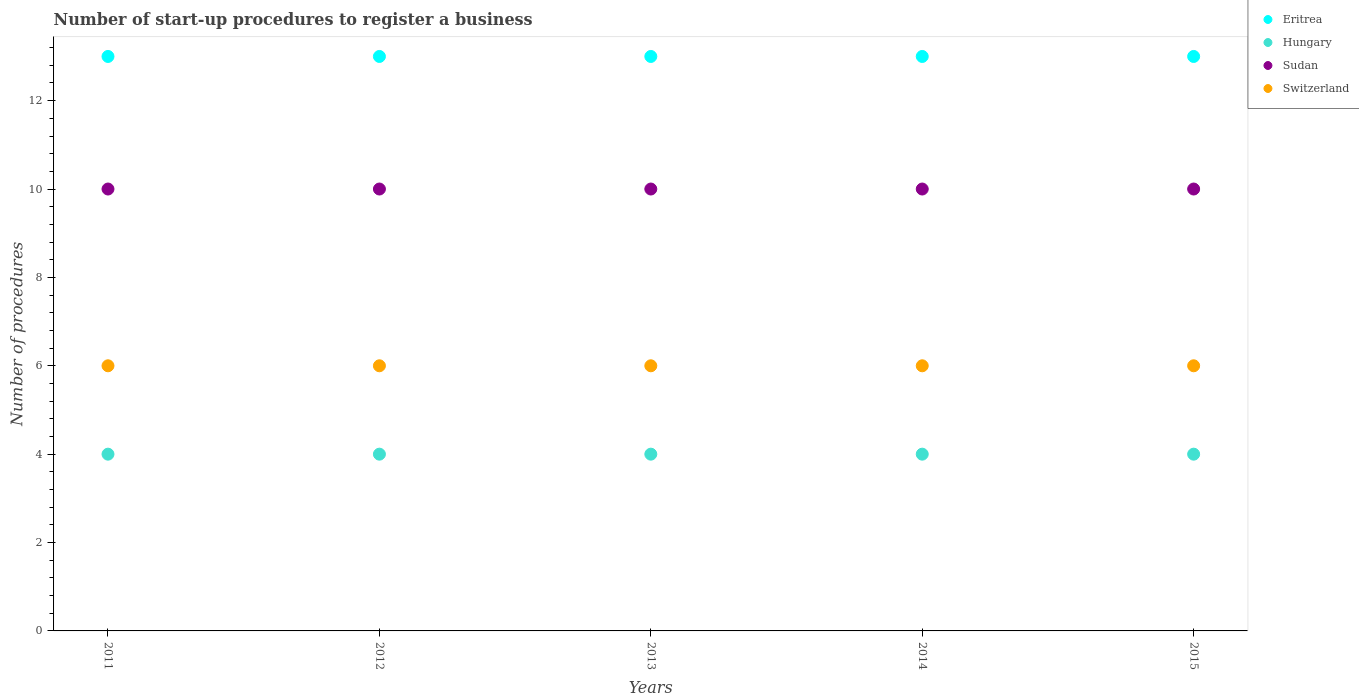What is the number of procedures required to register a business in Hungary in 2014?
Your answer should be very brief. 4. Across all years, what is the maximum number of procedures required to register a business in Switzerland?
Provide a succinct answer. 6. Across all years, what is the minimum number of procedures required to register a business in Hungary?
Your answer should be very brief. 4. In which year was the number of procedures required to register a business in Hungary minimum?
Your response must be concise. 2011. What is the difference between the number of procedures required to register a business in Hungary in 2011 and that in 2015?
Provide a short and direct response. 0. What is the difference between the number of procedures required to register a business in Hungary in 2014 and the number of procedures required to register a business in Switzerland in 2012?
Your answer should be compact. -2. What is the average number of procedures required to register a business in Switzerland per year?
Provide a short and direct response. 6. In the year 2012, what is the difference between the number of procedures required to register a business in Eritrea and number of procedures required to register a business in Hungary?
Make the answer very short. 9. Is the number of procedures required to register a business in Eritrea in 2011 less than that in 2012?
Make the answer very short. No. Is the difference between the number of procedures required to register a business in Eritrea in 2011 and 2012 greater than the difference between the number of procedures required to register a business in Hungary in 2011 and 2012?
Ensure brevity in your answer.  No. What is the difference between the highest and the lowest number of procedures required to register a business in Hungary?
Give a very brief answer. 0. Is the sum of the number of procedures required to register a business in Sudan in 2013 and 2014 greater than the maximum number of procedures required to register a business in Hungary across all years?
Your response must be concise. Yes. Is it the case that in every year, the sum of the number of procedures required to register a business in Switzerland and number of procedures required to register a business in Eritrea  is greater than the number of procedures required to register a business in Hungary?
Keep it short and to the point. Yes. Is the number of procedures required to register a business in Eritrea strictly greater than the number of procedures required to register a business in Sudan over the years?
Ensure brevity in your answer.  Yes. What is the difference between two consecutive major ticks on the Y-axis?
Your answer should be compact. 2. Are the values on the major ticks of Y-axis written in scientific E-notation?
Your answer should be very brief. No. What is the title of the graph?
Give a very brief answer. Number of start-up procedures to register a business. What is the label or title of the Y-axis?
Offer a terse response. Number of procedures. What is the Number of procedures of Hungary in 2011?
Provide a succinct answer. 4. What is the Number of procedures in Switzerland in 2011?
Ensure brevity in your answer.  6. What is the Number of procedures of Hungary in 2012?
Provide a succinct answer. 4. What is the Number of procedures of Switzerland in 2012?
Make the answer very short. 6. What is the Number of procedures in Eritrea in 2013?
Keep it short and to the point. 13. What is the Number of procedures in Hungary in 2013?
Keep it short and to the point. 4. What is the Number of procedures of Eritrea in 2014?
Provide a short and direct response. 13. What is the Number of procedures of Hungary in 2014?
Offer a terse response. 4. What is the Number of procedures of Sudan in 2014?
Provide a short and direct response. 10. What is the Number of procedures of Switzerland in 2014?
Make the answer very short. 6. What is the Number of procedures in Hungary in 2015?
Your answer should be compact. 4. Across all years, what is the maximum Number of procedures of Hungary?
Offer a very short reply. 4. Across all years, what is the minimum Number of procedures of Sudan?
Your response must be concise. 10. What is the total Number of procedures in Eritrea in the graph?
Offer a very short reply. 65. What is the total Number of procedures of Sudan in the graph?
Your answer should be very brief. 50. What is the total Number of procedures in Switzerland in the graph?
Offer a very short reply. 30. What is the difference between the Number of procedures in Hungary in 2011 and that in 2012?
Provide a short and direct response. 0. What is the difference between the Number of procedures of Switzerland in 2011 and that in 2012?
Offer a terse response. 0. What is the difference between the Number of procedures of Eritrea in 2011 and that in 2013?
Give a very brief answer. 0. What is the difference between the Number of procedures of Sudan in 2011 and that in 2013?
Make the answer very short. 0. What is the difference between the Number of procedures in Eritrea in 2011 and that in 2014?
Offer a very short reply. 0. What is the difference between the Number of procedures in Eritrea in 2011 and that in 2015?
Your answer should be compact. 0. What is the difference between the Number of procedures of Hungary in 2011 and that in 2015?
Make the answer very short. 0. What is the difference between the Number of procedures of Sudan in 2011 and that in 2015?
Keep it short and to the point. 0. What is the difference between the Number of procedures in Switzerland in 2011 and that in 2015?
Your response must be concise. 0. What is the difference between the Number of procedures in Hungary in 2012 and that in 2013?
Your response must be concise. 0. What is the difference between the Number of procedures of Switzerland in 2012 and that in 2013?
Make the answer very short. 0. What is the difference between the Number of procedures of Eritrea in 2012 and that in 2014?
Offer a very short reply. 0. What is the difference between the Number of procedures of Switzerland in 2012 and that in 2014?
Make the answer very short. 0. What is the difference between the Number of procedures in Eritrea in 2012 and that in 2015?
Your response must be concise. 0. What is the difference between the Number of procedures of Hungary in 2012 and that in 2015?
Make the answer very short. 0. What is the difference between the Number of procedures of Eritrea in 2013 and that in 2014?
Ensure brevity in your answer.  0. What is the difference between the Number of procedures of Hungary in 2013 and that in 2014?
Your response must be concise. 0. What is the difference between the Number of procedures in Switzerland in 2013 and that in 2014?
Make the answer very short. 0. What is the difference between the Number of procedures of Hungary in 2013 and that in 2015?
Keep it short and to the point. 0. What is the difference between the Number of procedures of Sudan in 2013 and that in 2015?
Make the answer very short. 0. What is the difference between the Number of procedures of Switzerland in 2013 and that in 2015?
Provide a succinct answer. 0. What is the difference between the Number of procedures of Eritrea in 2014 and that in 2015?
Provide a succinct answer. 0. What is the difference between the Number of procedures in Hungary in 2014 and that in 2015?
Make the answer very short. 0. What is the difference between the Number of procedures in Switzerland in 2014 and that in 2015?
Ensure brevity in your answer.  0. What is the difference between the Number of procedures in Eritrea in 2011 and the Number of procedures in Hungary in 2012?
Provide a short and direct response. 9. What is the difference between the Number of procedures of Eritrea in 2011 and the Number of procedures of Switzerland in 2012?
Offer a very short reply. 7. What is the difference between the Number of procedures in Hungary in 2011 and the Number of procedures in Sudan in 2012?
Provide a short and direct response. -6. What is the difference between the Number of procedures in Hungary in 2011 and the Number of procedures in Switzerland in 2012?
Your response must be concise. -2. What is the difference between the Number of procedures of Sudan in 2011 and the Number of procedures of Switzerland in 2012?
Your response must be concise. 4. What is the difference between the Number of procedures of Eritrea in 2011 and the Number of procedures of Hungary in 2013?
Make the answer very short. 9. What is the difference between the Number of procedures in Eritrea in 2011 and the Number of procedures in Sudan in 2013?
Keep it short and to the point. 3. What is the difference between the Number of procedures of Eritrea in 2011 and the Number of procedures of Switzerland in 2013?
Ensure brevity in your answer.  7. What is the difference between the Number of procedures of Hungary in 2011 and the Number of procedures of Sudan in 2013?
Your response must be concise. -6. What is the difference between the Number of procedures of Eritrea in 2011 and the Number of procedures of Sudan in 2014?
Your answer should be very brief. 3. What is the difference between the Number of procedures of Eritrea in 2011 and the Number of procedures of Switzerland in 2014?
Ensure brevity in your answer.  7. What is the difference between the Number of procedures in Eritrea in 2011 and the Number of procedures in Hungary in 2015?
Give a very brief answer. 9. What is the difference between the Number of procedures in Eritrea in 2011 and the Number of procedures in Sudan in 2015?
Offer a very short reply. 3. What is the difference between the Number of procedures of Hungary in 2011 and the Number of procedures of Sudan in 2015?
Provide a short and direct response. -6. What is the difference between the Number of procedures of Hungary in 2011 and the Number of procedures of Switzerland in 2015?
Your answer should be compact. -2. What is the difference between the Number of procedures of Sudan in 2011 and the Number of procedures of Switzerland in 2015?
Make the answer very short. 4. What is the difference between the Number of procedures in Hungary in 2012 and the Number of procedures in Sudan in 2013?
Ensure brevity in your answer.  -6. What is the difference between the Number of procedures of Hungary in 2012 and the Number of procedures of Switzerland in 2013?
Ensure brevity in your answer.  -2. What is the difference between the Number of procedures of Eritrea in 2012 and the Number of procedures of Hungary in 2014?
Keep it short and to the point. 9. What is the difference between the Number of procedures in Eritrea in 2012 and the Number of procedures in Switzerland in 2014?
Keep it short and to the point. 7. What is the difference between the Number of procedures in Hungary in 2012 and the Number of procedures in Sudan in 2014?
Provide a short and direct response. -6. What is the difference between the Number of procedures in Hungary in 2012 and the Number of procedures in Switzerland in 2014?
Ensure brevity in your answer.  -2. What is the difference between the Number of procedures in Eritrea in 2012 and the Number of procedures in Sudan in 2015?
Keep it short and to the point. 3. What is the difference between the Number of procedures in Hungary in 2012 and the Number of procedures in Sudan in 2015?
Ensure brevity in your answer.  -6. What is the difference between the Number of procedures of Hungary in 2012 and the Number of procedures of Switzerland in 2015?
Ensure brevity in your answer.  -2. What is the difference between the Number of procedures in Eritrea in 2013 and the Number of procedures in Sudan in 2014?
Your response must be concise. 3. What is the difference between the Number of procedures in Hungary in 2013 and the Number of procedures in Sudan in 2014?
Keep it short and to the point. -6. What is the difference between the Number of procedures of Eritrea in 2013 and the Number of procedures of Hungary in 2015?
Your response must be concise. 9. What is the difference between the Number of procedures of Eritrea in 2013 and the Number of procedures of Switzerland in 2015?
Offer a very short reply. 7. What is the difference between the Number of procedures in Hungary in 2013 and the Number of procedures in Sudan in 2015?
Give a very brief answer. -6. What is the difference between the Number of procedures in Sudan in 2013 and the Number of procedures in Switzerland in 2015?
Give a very brief answer. 4. What is the difference between the Number of procedures of Hungary in 2014 and the Number of procedures of Sudan in 2015?
Make the answer very short. -6. What is the difference between the Number of procedures of Sudan in 2014 and the Number of procedures of Switzerland in 2015?
Your answer should be very brief. 4. What is the average Number of procedures of Sudan per year?
Provide a short and direct response. 10. What is the average Number of procedures in Switzerland per year?
Make the answer very short. 6. In the year 2011, what is the difference between the Number of procedures in Hungary and Number of procedures in Sudan?
Offer a very short reply. -6. In the year 2012, what is the difference between the Number of procedures in Eritrea and Number of procedures in Sudan?
Make the answer very short. 3. In the year 2012, what is the difference between the Number of procedures of Sudan and Number of procedures of Switzerland?
Your answer should be compact. 4. In the year 2013, what is the difference between the Number of procedures in Eritrea and Number of procedures in Hungary?
Provide a succinct answer. 9. In the year 2013, what is the difference between the Number of procedures in Hungary and Number of procedures in Switzerland?
Keep it short and to the point. -2. In the year 2013, what is the difference between the Number of procedures in Sudan and Number of procedures in Switzerland?
Offer a terse response. 4. In the year 2014, what is the difference between the Number of procedures of Eritrea and Number of procedures of Hungary?
Offer a very short reply. 9. In the year 2014, what is the difference between the Number of procedures of Sudan and Number of procedures of Switzerland?
Offer a very short reply. 4. In the year 2015, what is the difference between the Number of procedures in Eritrea and Number of procedures in Hungary?
Offer a terse response. 9. In the year 2015, what is the difference between the Number of procedures in Hungary and Number of procedures in Switzerland?
Your answer should be compact. -2. In the year 2015, what is the difference between the Number of procedures of Sudan and Number of procedures of Switzerland?
Your answer should be very brief. 4. What is the ratio of the Number of procedures of Eritrea in 2011 to that in 2012?
Keep it short and to the point. 1. What is the ratio of the Number of procedures in Sudan in 2011 to that in 2012?
Provide a succinct answer. 1. What is the ratio of the Number of procedures in Switzerland in 2011 to that in 2012?
Offer a very short reply. 1. What is the ratio of the Number of procedures in Eritrea in 2011 to that in 2013?
Provide a short and direct response. 1. What is the ratio of the Number of procedures in Hungary in 2011 to that in 2013?
Make the answer very short. 1. What is the ratio of the Number of procedures of Eritrea in 2011 to that in 2014?
Your answer should be compact. 1. What is the ratio of the Number of procedures of Hungary in 2011 to that in 2014?
Give a very brief answer. 1. What is the ratio of the Number of procedures in Switzerland in 2011 to that in 2014?
Provide a short and direct response. 1. What is the ratio of the Number of procedures of Eritrea in 2012 to that in 2013?
Give a very brief answer. 1. What is the ratio of the Number of procedures of Sudan in 2012 to that in 2013?
Provide a succinct answer. 1. What is the ratio of the Number of procedures in Eritrea in 2012 to that in 2014?
Ensure brevity in your answer.  1. What is the ratio of the Number of procedures in Switzerland in 2012 to that in 2014?
Give a very brief answer. 1. What is the ratio of the Number of procedures in Hungary in 2013 to that in 2014?
Provide a short and direct response. 1. What is the ratio of the Number of procedures of Sudan in 2013 to that in 2014?
Your answer should be very brief. 1. What is the ratio of the Number of procedures of Eritrea in 2013 to that in 2015?
Give a very brief answer. 1. What is the ratio of the Number of procedures of Sudan in 2013 to that in 2015?
Ensure brevity in your answer.  1. What is the ratio of the Number of procedures of Hungary in 2014 to that in 2015?
Offer a very short reply. 1. What is the difference between the highest and the second highest Number of procedures of Sudan?
Provide a succinct answer. 0. What is the difference between the highest and the second highest Number of procedures in Switzerland?
Give a very brief answer. 0. What is the difference between the highest and the lowest Number of procedures of Eritrea?
Your answer should be compact. 0. What is the difference between the highest and the lowest Number of procedures in Hungary?
Provide a short and direct response. 0. What is the difference between the highest and the lowest Number of procedures in Sudan?
Your response must be concise. 0. What is the difference between the highest and the lowest Number of procedures in Switzerland?
Your answer should be compact. 0. 